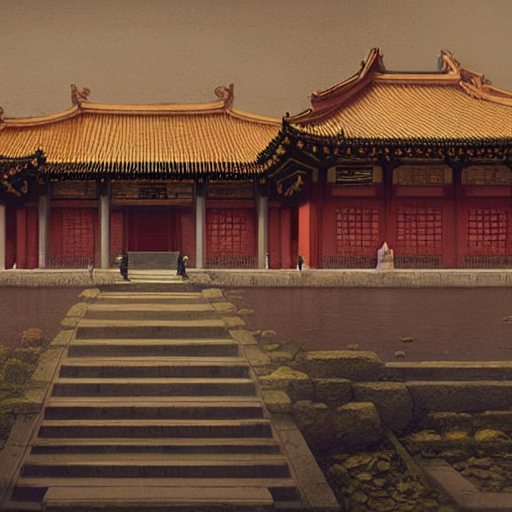Can you describe the architectural style depicted in this image? The architecture in this image features traditional East Asian influences, characterized by sweeping, upturned gable roofs with ornate ridges and a bright color scheme, primarily red; it's commonly seen in historical buildings throughout China. The symmetry and the use of tiered platforms are also indicative of this style, designed to represent harmony and balance. 